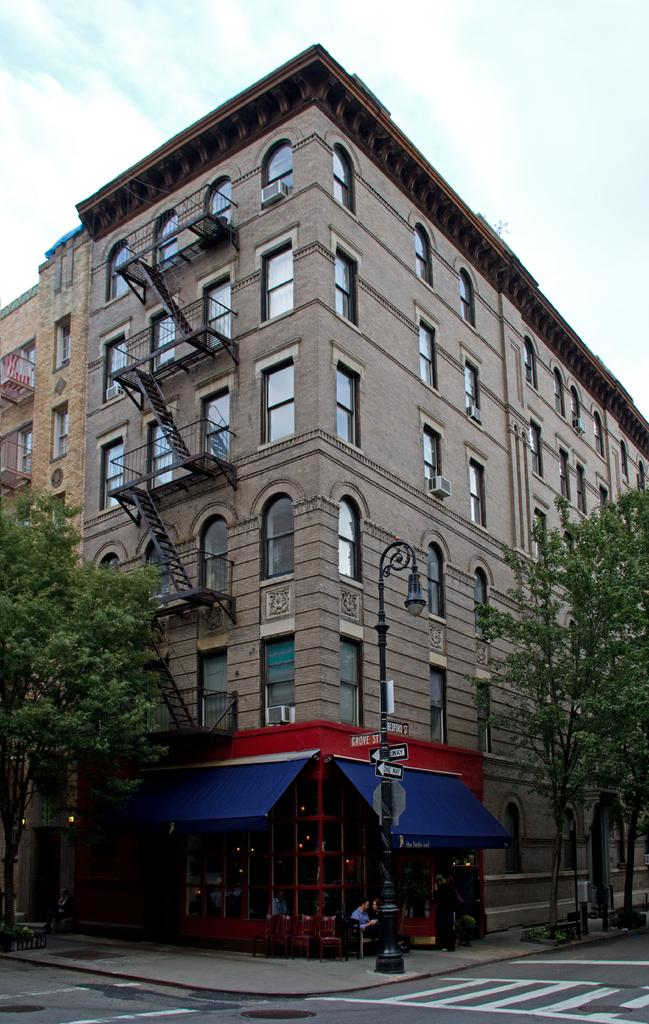What is located in the center of the image? There are trees, a building, staircases, windows, and a street light present in the center of the image. Can you describe the building in the center of the image? The building in the center of the image has windows and staircases. What type of lighting is present in the center of the image? A street light is present in the center of the image. What is the foreground of the image? The foreground of the image consists of a road. What is the size of the car in the image? There is no car present in the image. In which country is the image taken? The provided facts do not mention the country where the image was taken. 